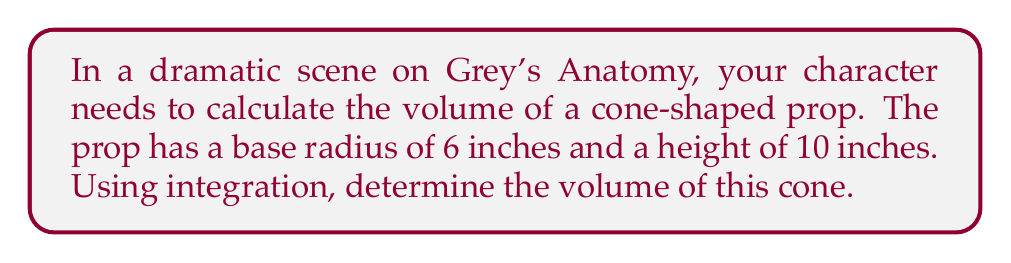Help me with this question. To find the volume of a cone using integration, we'll follow these steps:

1) The volume of a cone can be found by integrating the area of circular cross-sections from the base to the apex.

2) The radius of each cross-section varies with height. We need to express r in terms of h:
   $r = R(1 - \frac{h}{H})$, where R is the base radius and H is the height.

3) The volume formula using integration is:
   $$V = \int_0^H \pi r^2 dh$$

4) Substituting our r expression:
   $$V = \int_0^H \pi [R(1 - \frac{h}{H})]^2 dh$$

5) Expanding the square:
   $$V = \pi R^2 \int_0^H (1 - \frac{2h}{H} + \frac{h^2}{H^2}) dh$$

6) Integrating:
   $$V = \pi R^2 [h - \frac{h^2}{H} + \frac{h^3}{3H^2}]_0^H$$

7) Evaluating from 0 to H:
   $$V = \pi R^2 [(H - \frac{H^2}{H} + \frac{H^3}{3H^2}) - (0 - 0 + 0)]$$

8) Simplifying:
   $$V = \pi R^2 (H - H + \frac{H}{3}) = \frac{1}{3}\pi R^2 H$$

9) Plugging in our values (R = 6 inches, H = 10 inches):
   $$V = \frac{1}{3}\pi (6^2)(10) = 120\pi \approx 376.99 \text{ cubic inches}$$
Answer: $\frac{1}{3}\pi R^2 H = 120\pi \approx 376.99 \text{ cubic inches}$ 